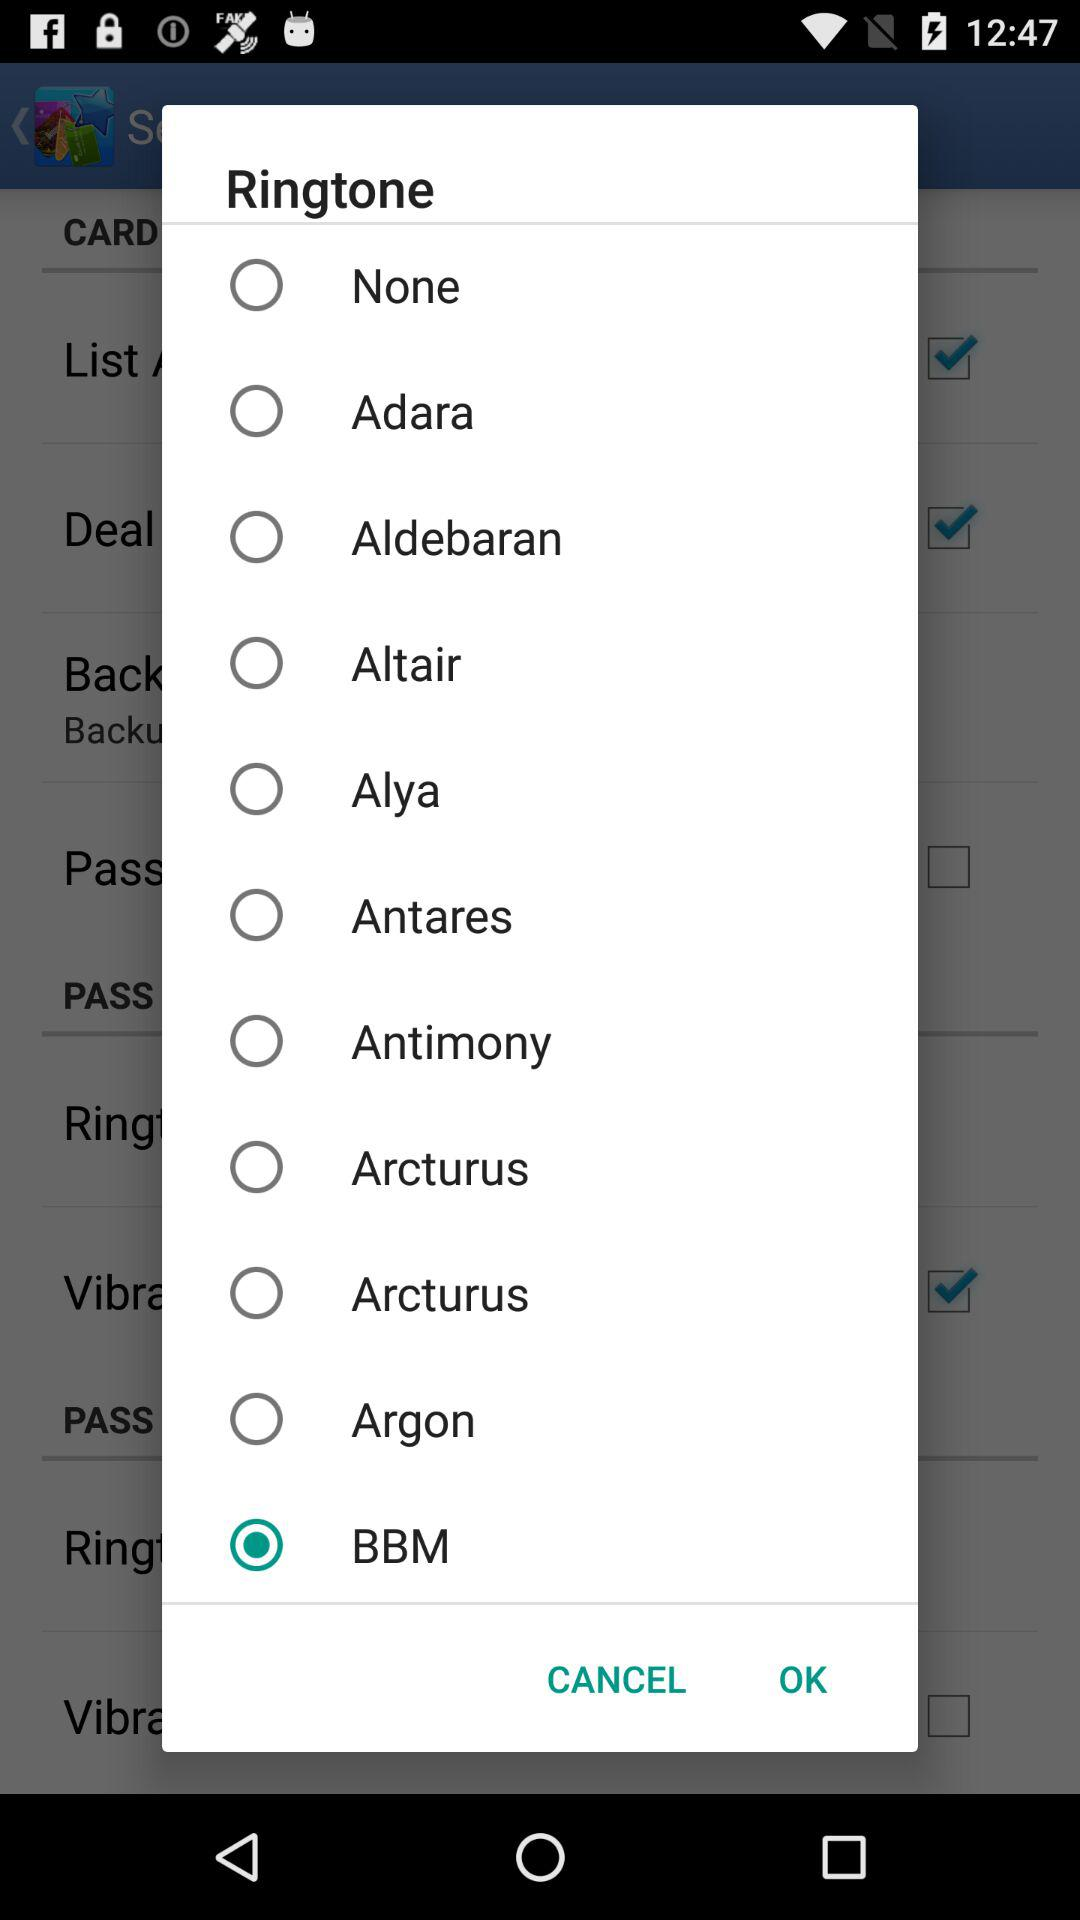Which ringtone is selected? The selected ringtone is "BBM". 